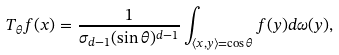<formula> <loc_0><loc_0><loc_500><loc_500>T _ { \theta } f ( x ) = \frac { 1 } { \sigma _ { d - 1 } ( \sin \theta ) ^ { d - 1 } } \int _ { \langle x , y \rangle = \cos \theta } f ( y ) d \omega ( y ) ,</formula> 